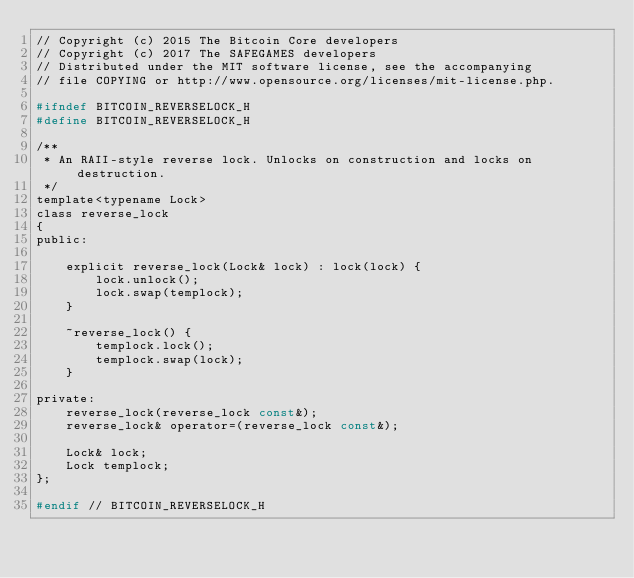Convert code to text. <code><loc_0><loc_0><loc_500><loc_500><_C_>// Copyright (c) 2015 The Bitcoin Core developers
// Copyright (c) 2017 The SAFEGAMES developers
// Distributed under the MIT software license, see the accompanying
// file COPYING or http://www.opensource.org/licenses/mit-license.php.

#ifndef BITCOIN_REVERSELOCK_H
#define BITCOIN_REVERSELOCK_H

/**
 * An RAII-style reverse lock. Unlocks on construction and locks on destruction.
 */
template<typename Lock>
class reverse_lock
{
public:

    explicit reverse_lock(Lock& lock) : lock(lock) {
        lock.unlock();
        lock.swap(templock);
    }

    ~reverse_lock() {
        templock.lock();
        templock.swap(lock);
    }

private:
    reverse_lock(reverse_lock const&);
    reverse_lock& operator=(reverse_lock const&);

    Lock& lock;
    Lock templock;
};

#endif // BITCOIN_REVERSELOCK_H
</code> 